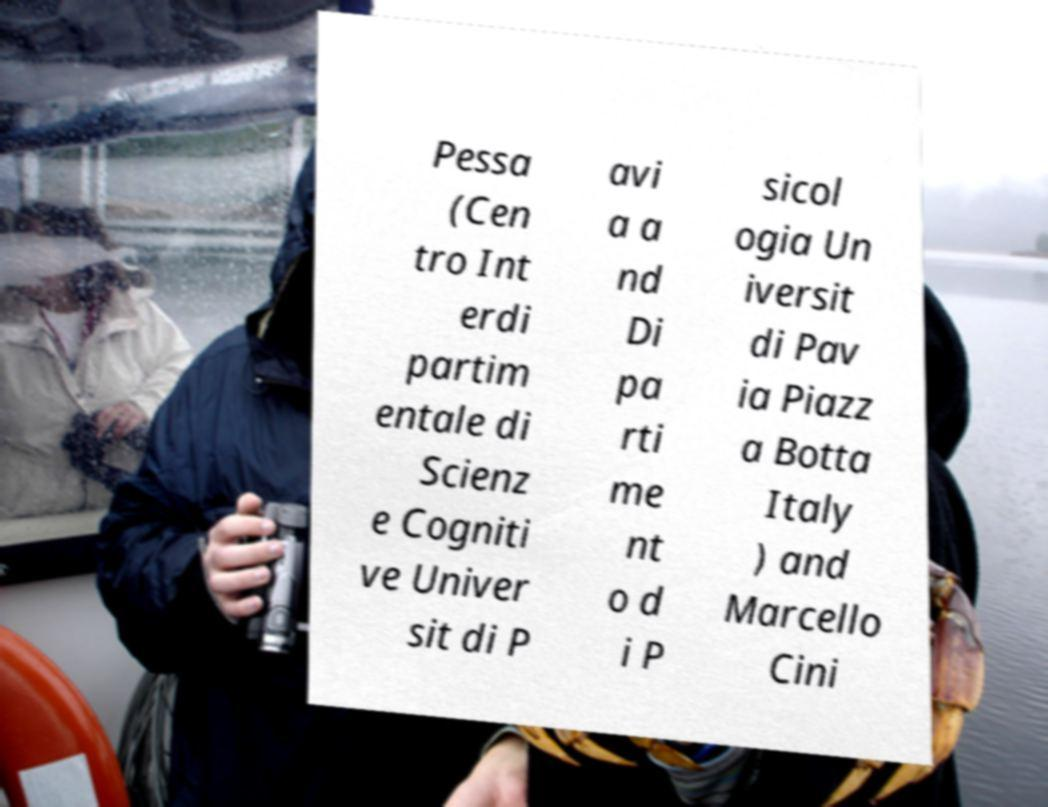Please read and relay the text visible in this image. What does it say? Pessa (Cen tro Int erdi partim entale di Scienz e Cogniti ve Univer sit di P avi a a nd Di pa rti me nt o d i P sicol ogia Un iversit di Pav ia Piazz a Botta Italy ) and Marcello Cini 